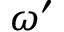Convert formula to latex. <formula><loc_0><loc_0><loc_500><loc_500>\omega ^ { \prime }</formula> 